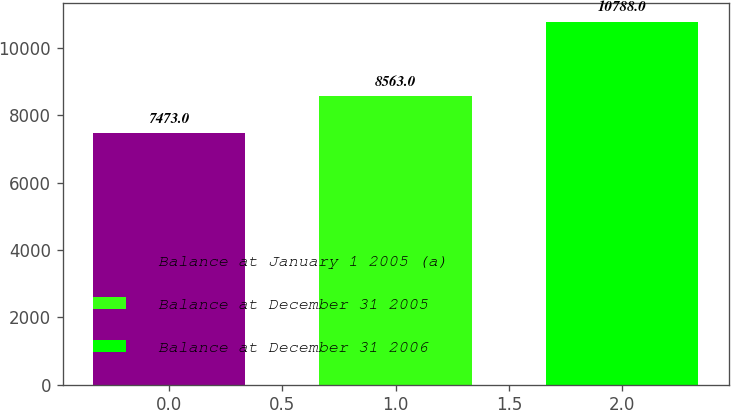Convert chart to OTSL. <chart><loc_0><loc_0><loc_500><loc_500><bar_chart><fcel>Balance at January 1 2005 (a)<fcel>Balance at December 31 2005<fcel>Balance at December 31 2006<nl><fcel>7473<fcel>8563<fcel>10788<nl></chart> 